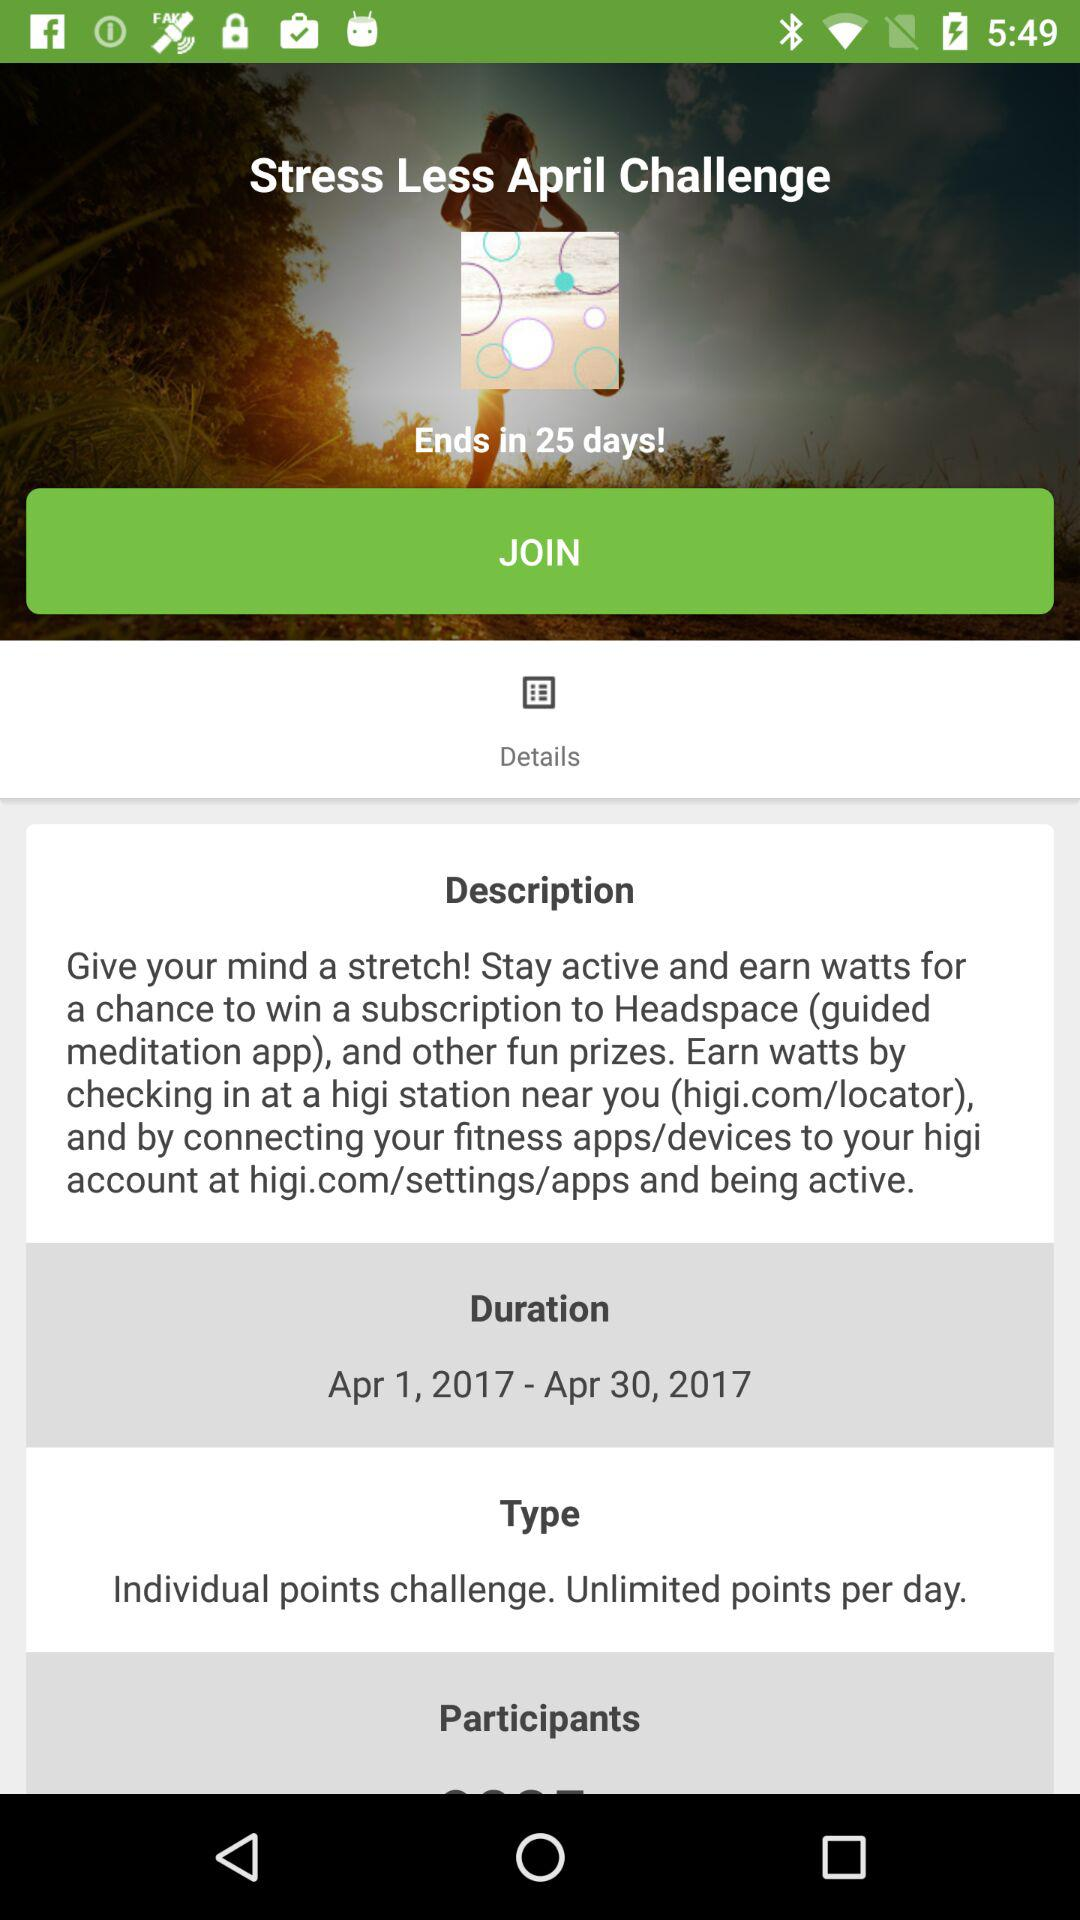What is the type? The type is "Individual points challenge. Unlimited points per day". 